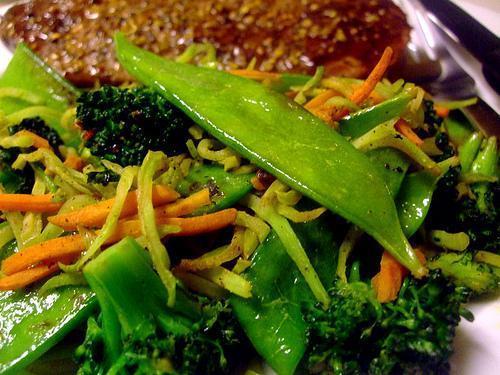How many broccolis are in the photo?
Give a very brief answer. 3. How many carrots can be seen?
Give a very brief answer. 2. 